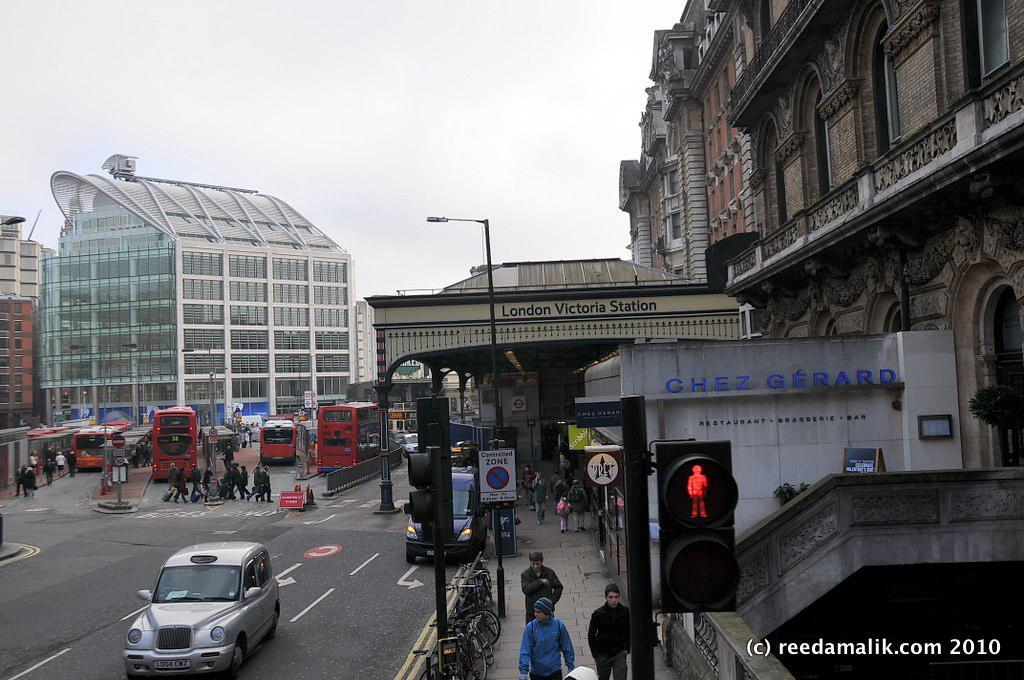<image>
Render a clear and concise summary of the photo. Several buses are outside of London Victoria Station. 